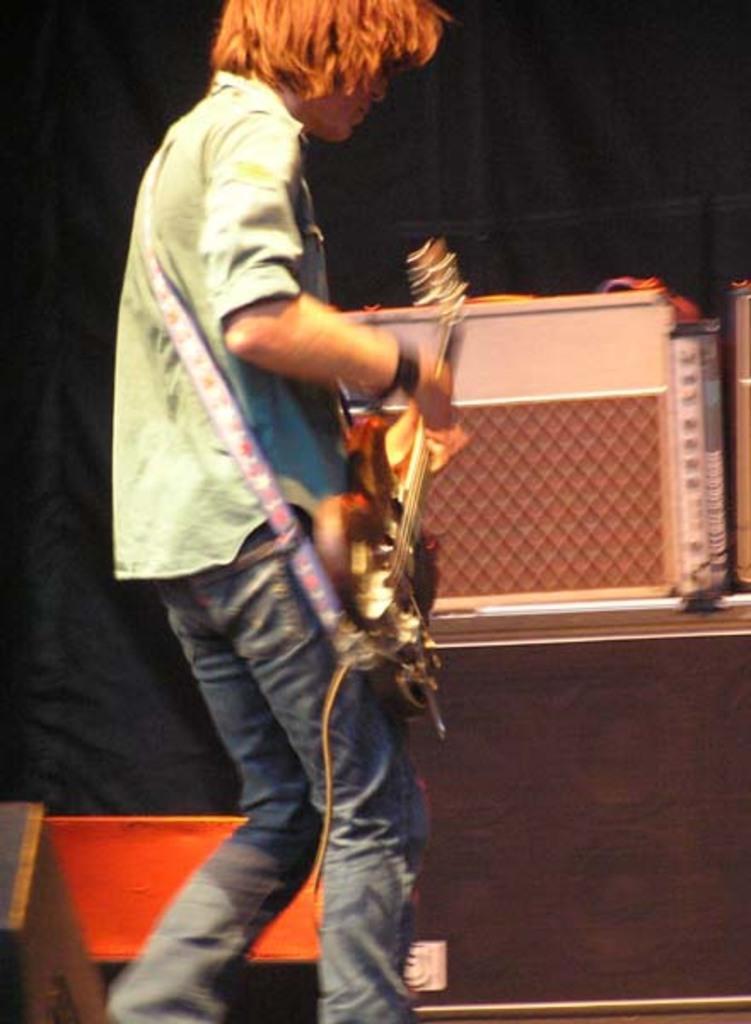In one or two sentences, can you explain what this image depicts? There is a man standing on stage playing a guitar. 